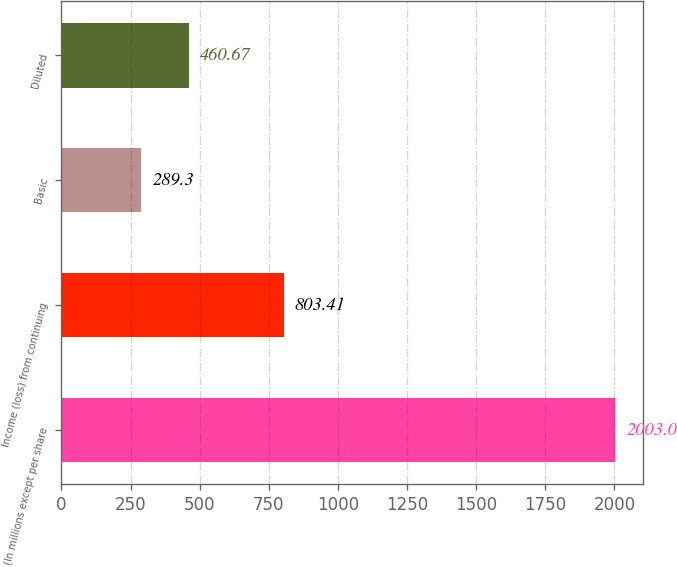<chart> <loc_0><loc_0><loc_500><loc_500><bar_chart><fcel>(In millions except per share<fcel>Income (loss) from continuing<fcel>Basic<fcel>Diluted<nl><fcel>2003<fcel>803.41<fcel>289.3<fcel>460.67<nl></chart> 